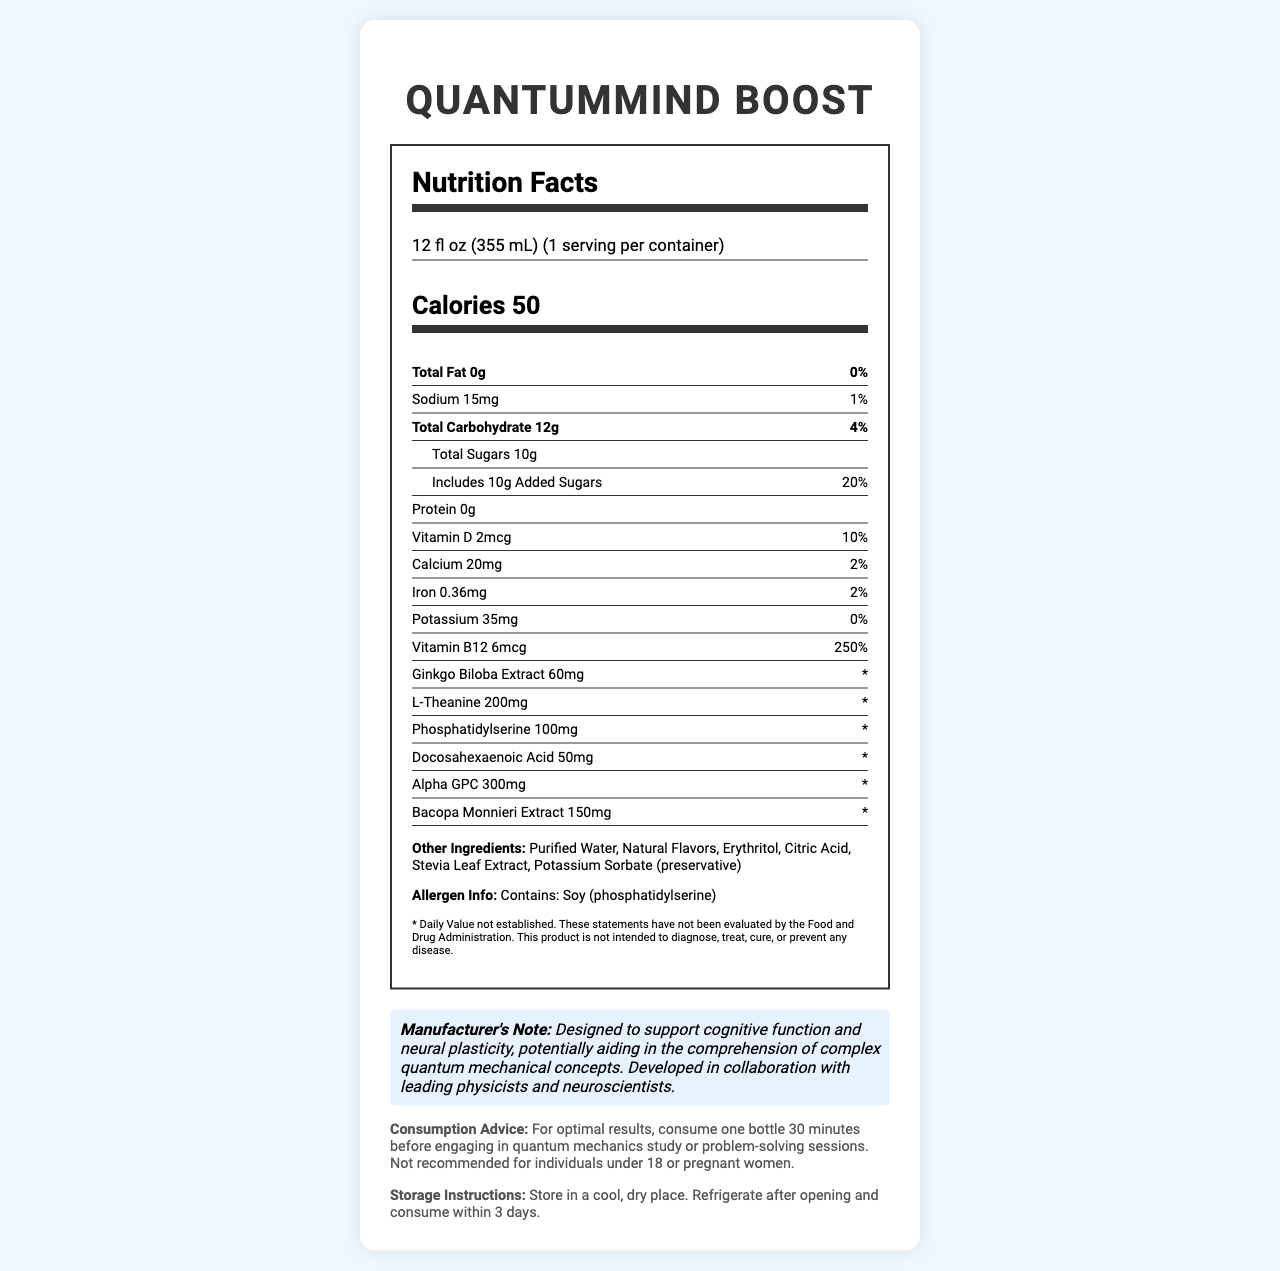what is the serving size of QuantumMind Boost? The serving size is clearly stated at the top of the nutrition facts section under the product name.
Answer: 12 fl oz (355 mL) how many calories are in one serving of QuantumMind Boost? The calorie count is displayed prominently right below the serving size information.
Answer: 50 how much total fat is in a serving of QuantumMind Boost? The total fat amount and its daily value percentage are shown under the nutrient info section.
Answer: 0g what is the daily value percentage of added sugars in QuantumMind Boost? The label lists the added sugars at 10g and specifies that this is 20% of the daily value.
Answer: 20% how much Vitamin B12 is in QuantumMind Boost, and what is its daily value percentage? The amount and daily value percentage of Vitamin B12 are shown in the nutrient info section.
Answer: 6mcg, 250% which of the following ingredients is not included in QuantumMind Boost? A. Erythritol B. Artificial Flavors C. Stevia Leaf Extract D. Potassium Sorbate The list of other ingredients shows Erythritol, Stevia Leaf Extract, and Potassium Sorbate, but no artificial flavors.
Answer: B. Artificial Flavors what is the recommended consumption advice for QuantumMind Boost? A. Consume one bottle every morning B. Consume one bottle before exercise C. Consume one bottle 30 minutes before engaging in quantum mechanics study D. Consume one bottle with meals The consumption advice section mentions consuming one bottle 30 minutes before studying quantum mechanics.
Answer: C. Consume one bottle 30 minutes before engaging in quantum mechanics study does QuantumMind Boost contain any protein? The protein content is listed as 0g in the nutrient info section.
Answer: No summarize the main information provided in this document. The document primarily details the nutritional content, key ingredients, and specific consumption and storage recommendations for the QuantumMind Boost beverage, aiming to support cognitive functions.
Answer: This document is a Nutrition Facts Label for a vitamin-fortified beverage called QuantumMind Boost, designed to enhance neural plasticity and aid in understanding quantum mechanics. It lists the serving size, calorie count, and various nutrient and ingredient information. The beverage contains various cognitive support ingredients like Ginkgo Biloba Extract, L-Theanine, and Bacopa Monnieri Extract. It also includes consumption advice and storage instructions. who is the manufacturer of QuantumMind Boost? The document does not provide any specific manufacturer information.
Answer: Not enough information how should QuantumMind Boost be stored after opening? The storage instructions suggest refrigerating the beverage and consuming it within 3 days after opening.
Answer: Refrigerate and consume within 3 days 